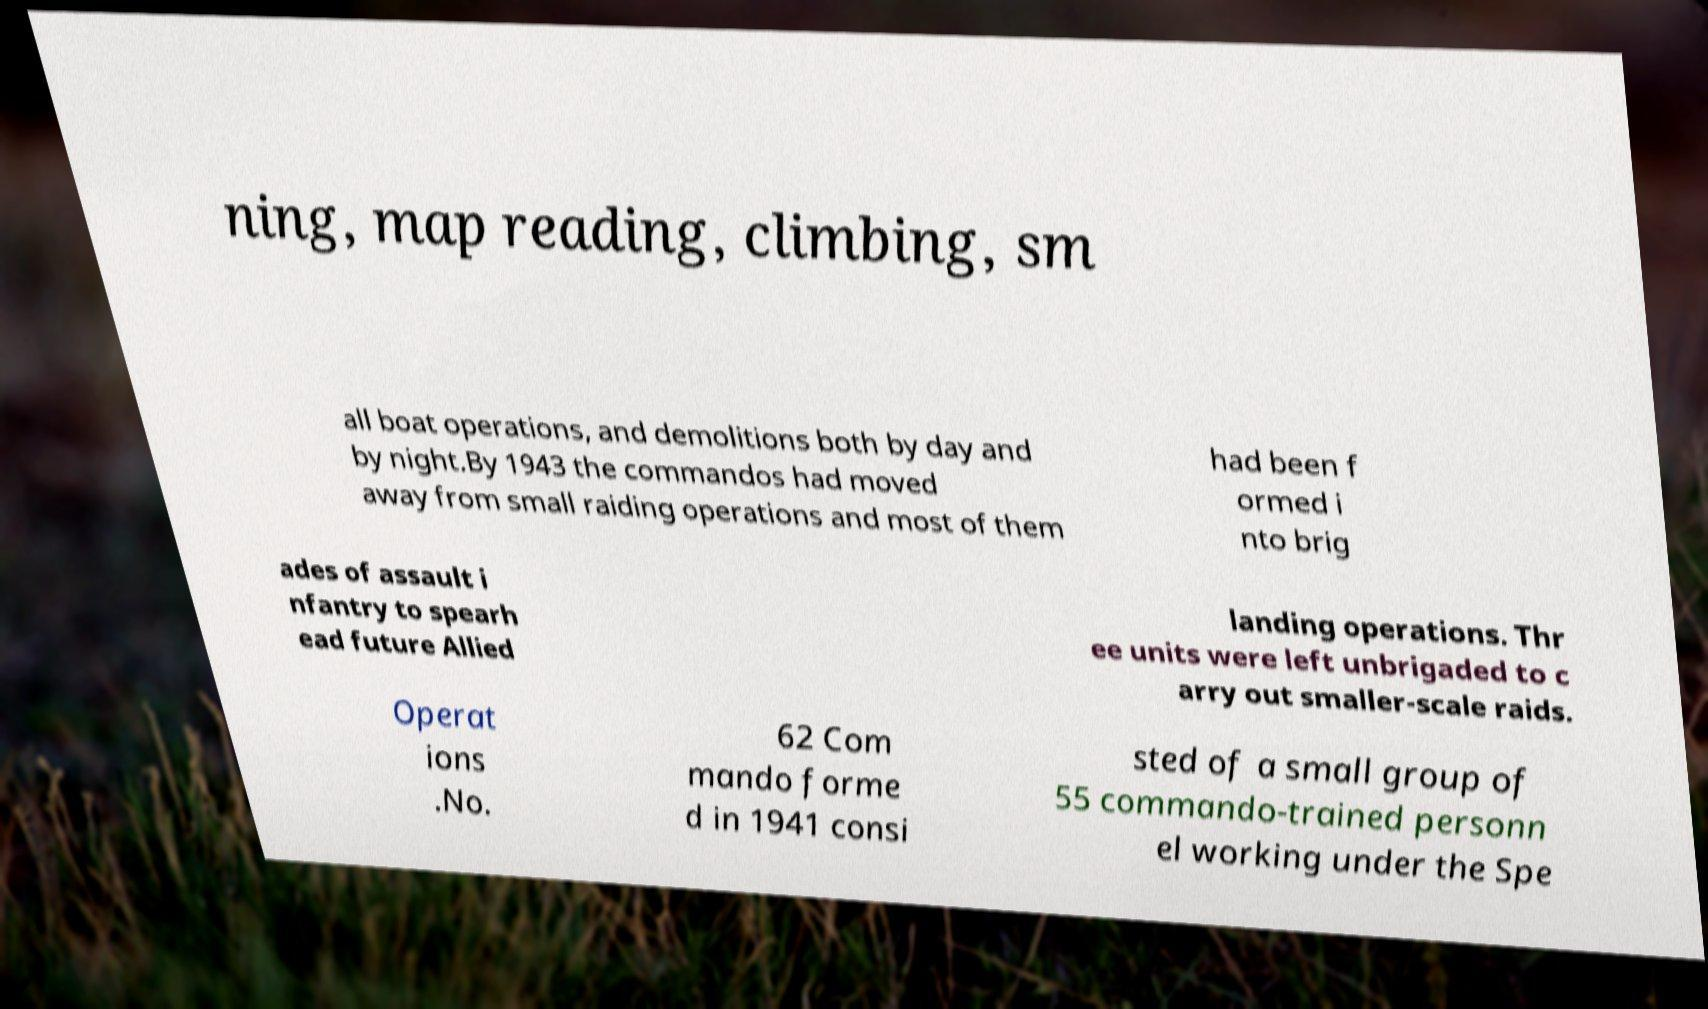For documentation purposes, I need the text within this image transcribed. Could you provide that? ning, map reading, climbing, sm all boat operations, and demolitions both by day and by night.By 1943 the commandos had moved away from small raiding operations and most of them had been f ormed i nto brig ades of assault i nfantry to spearh ead future Allied landing operations. Thr ee units were left unbrigaded to c arry out smaller-scale raids. Operat ions .No. 62 Com mando forme d in 1941 consi sted of a small group of 55 commando-trained personn el working under the Spe 